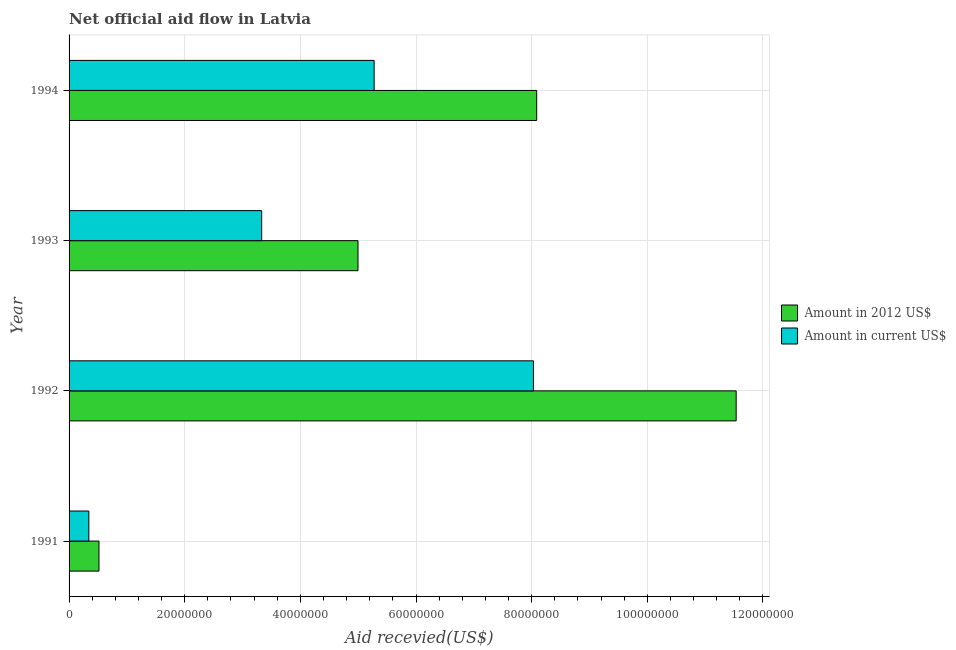How many bars are there on the 1st tick from the top?
Your answer should be very brief. 2. How many bars are there on the 2nd tick from the bottom?
Keep it short and to the point. 2. What is the amount of aid received(expressed in 2012 us$) in 1991?
Provide a short and direct response. 5.17e+06. Across all years, what is the maximum amount of aid received(expressed in us$)?
Ensure brevity in your answer.  8.03e+07. Across all years, what is the minimum amount of aid received(expressed in us$)?
Offer a terse response. 3.42e+06. In which year was the amount of aid received(expressed in us$) maximum?
Provide a succinct answer. 1992. What is the total amount of aid received(expressed in 2012 us$) in the graph?
Your answer should be very brief. 2.51e+08. What is the difference between the amount of aid received(expressed in us$) in 1991 and that in 1992?
Your answer should be very brief. -7.69e+07. What is the difference between the amount of aid received(expressed in us$) in 1991 and the amount of aid received(expressed in 2012 us$) in 1992?
Ensure brevity in your answer.  -1.12e+08. What is the average amount of aid received(expressed in us$) per year?
Offer a terse response. 4.24e+07. In the year 1993, what is the difference between the amount of aid received(expressed in 2012 us$) and amount of aid received(expressed in us$)?
Provide a succinct answer. 1.67e+07. What is the ratio of the amount of aid received(expressed in 2012 us$) in 1991 to that in 1992?
Give a very brief answer. 0.04. Is the amount of aid received(expressed in 2012 us$) in 1991 less than that in 1992?
Keep it short and to the point. Yes. Is the difference between the amount of aid received(expressed in 2012 us$) in 1992 and 1993 greater than the difference between the amount of aid received(expressed in us$) in 1992 and 1993?
Your answer should be very brief. Yes. What is the difference between the highest and the second highest amount of aid received(expressed in 2012 us$)?
Make the answer very short. 3.45e+07. What is the difference between the highest and the lowest amount of aid received(expressed in us$)?
Provide a succinct answer. 7.69e+07. In how many years, is the amount of aid received(expressed in 2012 us$) greater than the average amount of aid received(expressed in 2012 us$) taken over all years?
Keep it short and to the point. 2. Is the sum of the amount of aid received(expressed in 2012 us$) in 1992 and 1993 greater than the maximum amount of aid received(expressed in us$) across all years?
Provide a succinct answer. Yes. What does the 1st bar from the top in 1992 represents?
Offer a terse response. Amount in current US$. What does the 1st bar from the bottom in 1991 represents?
Give a very brief answer. Amount in 2012 US$. How many bars are there?
Your answer should be very brief. 8. Are all the bars in the graph horizontal?
Your answer should be compact. Yes. How many years are there in the graph?
Your response must be concise. 4. What is the difference between two consecutive major ticks on the X-axis?
Ensure brevity in your answer.  2.00e+07. Does the graph contain grids?
Your answer should be compact. Yes. How many legend labels are there?
Provide a short and direct response. 2. How are the legend labels stacked?
Your response must be concise. Vertical. What is the title of the graph?
Offer a very short reply. Net official aid flow in Latvia. Does "Number of arrivals" appear as one of the legend labels in the graph?
Make the answer very short. No. What is the label or title of the X-axis?
Keep it short and to the point. Aid recevied(US$). What is the label or title of the Y-axis?
Your answer should be compact. Year. What is the Aid recevied(US$) of Amount in 2012 US$ in 1991?
Ensure brevity in your answer.  5.17e+06. What is the Aid recevied(US$) in Amount in current US$ in 1991?
Give a very brief answer. 3.42e+06. What is the Aid recevied(US$) of Amount in 2012 US$ in 1992?
Your response must be concise. 1.15e+08. What is the Aid recevied(US$) of Amount in current US$ in 1992?
Your response must be concise. 8.03e+07. What is the Aid recevied(US$) of Amount in 2012 US$ in 1993?
Your answer should be very brief. 5.00e+07. What is the Aid recevied(US$) of Amount in current US$ in 1993?
Ensure brevity in your answer.  3.33e+07. What is the Aid recevied(US$) of Amount in 2012 US$ in 1994?
Your answer should be very brief. 8.09e+07. What is the Aid recevied(US$) in Amount in current US$ in 1994?
Your answer should be very brief. 5.28e+07. Across all years, what is the maximum Aid recevied(US$) of Amount in 2012 US$?
Your answer should be very brief. 1.15e+08. Across all years, what is the maximum Aid recevied(US$) of Amount in current US$?
Provide a short and direct response. 8.03e+07. Across all years, what is the minimum Aid recevied(US$) in Amount in 2012 US$?
Make the answer very short. 5.17e+06. Across all years, what is the minimum Aid recevied(US$) in Amount in current US$?
Make the answer very short. 3.42e+06. What is the total Aid recevied(US$) in Amount in 2012 US$ in the graph?
Your response must be concise. 2.51e+08. What is the total Aid recevied(US$) in Amount in current US$ in the graph?
Ensure brevity in your answer.  1.70e+08. What is the difference between the Aid recevied(US$) of Amount in 2012 US$ in 1991 and that in 1992?
Offer a very short reply. -1.10e+08. What is the difference between the Aid recevied(US$) of Amount in current US$ in 1991 and that in 1992?
Your answer should be very brief. -7.69e+07. What is the difference between the Aid recevied(US$) of Amount in 2012 US$ in 1991 and that in 1993?
Offer a terse response. -4.48e+07. What is the difference between the Aid recevied(US$) of Amount in current US$ in 1991 and that in 1993?
Offer a terse response. -2.99e+07. What is the difference between the Aid recevied(US$) in Amount in 2012 US$ in 1991 and that in 1994?
Ensure brevity in your answer.  -7.57e+07. What is the difference between the Aid recevied(US$) of Amount in current US$ in 1991 and that in 1994?
Give a very brief answer. -4.93e+07. What is the difference between the Aid recevied(US$) of Amount in 2012 US$ in 1992 and that in 1993?
Your response must be concise. 6.54e+07. What is the difference between the Aid recevied(US$) in Amount in current US$ in 1992 and that in 1993?
Make the answer very short. 4.70e+07. What is the difference between the Aid recevied(US$) of Amount in 2012 US$ in 1992 and that in 1994?
Your answer should be compact. 3.45e+07. What is the difference between the Aid recevied(US$) in Amount in current US$ in 1992 and that in 1994?
Your response must be concise. 2.76e+07. What is the difference between the Aid recevied(US$) in Amount in 2012 US$ in 1993 and that in 1994?
Keep it short and to the point. -3.09e+07. What is the difference between the Aid recevied(US$) in Amount in current US$ in 1993 and that in 1994?
Offer a very short reply. -1.94e+07. What is the difference between the Aid recevied(US$) of Amount in 2012 US$ in 1991 and the Aid recevied(US$) of Amount in current US$ in 1992?
Ensure brevity in your answer.  -7.51e+07. What is the difference between the Aid recevied(US$) in Amount in 2012 US$ in 1991 and the Aid recevied(US$) in Amount in current US$ in 1993?
Ensure brevity in your answer.  -2.81e+07. What is the difference between the Aid recevied(US$) in Amount in 2012 US$ in 1991 and the Aid recevied(US$) in Amount in current US$ in 1994?
Your response must be concise. -4.76e+07. What is the difference between the Aid recevied(US$) in Amount in 2012 US$ in 1992 and the Aid recevied(US$) in Amount in current US$ in 1993?
Your answer should be compact. 8.21e+07. What is the difference between the Aid recevied(US$) in Amount in 2012 US$ in 1992 and the Aid recevied(US$) in Amount in current US$ in 1994?
Provide a short and direct response. 6.26e+07. What is the difference between the Aid recevied(US$) in Amount in 2012 US$ in 1993 and the Aid recevied(US$) in Amount in current US$ in 1994?
Provide a short and direct response. -2.79e+06. What is the average Aid recevied(US$) of Amount in 2012 US$ per year?
Make the answer very short. 6.28e+07. What is the average Aid recevied(US$) in Amount in current US$ per year?
Provide a short and direct response. 4.24e+07. In the year 1991, what is the difference between the Aid recevied(US$) in Amount in 2012 US$ and Aid recevied(US$) in Amount in current US$?
Give a very brief answer. 1.75e+06. In the year 1992, what is the difference between the Aid recevied(US$) in Amount in 2012 US$ and Aid recevied(US$) in Amount in current US$?
Provide a succinct answer. 3.51e+07. In the year 1993, what is the difference between the Aid recevied(US$) in Amount in 2012 US$ and Aid recevied(US$) in Amount in current US$?
Keep it short and to the point. 1.67e+07. In the year 1994, what is the difference between the Aid recevied(US$) of Amount in 2012 US$ and Aid recevied(US$) of Amount in current US$?
Provide a short and direct response. 2.81e+07. What is the ratio of the Aid recevied(US$) in Amount in 2012 US$ in 1991 to that in 1992?
Provide a succinct answer. 0.04. What is the ratio of the Aid recevied(US$) of Amount in current US$ in 1991 to that in 1992?
Give a very brief answer. 0.04. What is the ratio of the Aid recevied(US$) in Amount in 2012 US$ in 1991 to that in 1993?
Provide a short and direct response. 0.1. What is the ratio of the Aid recevied(US$) in Amount in current US$ in 1991 to that in 1993?
Provide a short and direct response. 0.1. What is the ratio of the Aid recevied(US$) in Amount in 2012 US$ in 1991 to that in 1994?
Make the answer very short. 0.06. What is the ratio of the Aid recevied(US$) of Amount in current US$ in 1991 to that in 1994?
Ensure brevity in your answer.  0.06. What is the ratio of the Aid recevied(US$) of Amount in 2012 US$ in 1992 to that in 1993?
Keep it short and to the point. 2.31. What is the ratio of the Aid recevied(US$) in Amount in current US$ in 1992 to that in 1993?
Provide a short and direct response. 2.41. What is the ratio of the Aid recevied(US$) of Amount in 2012 US$ in 1992 to that in 1994?
Ensure brevity in your answer.  1.43. What is the ratio of the Aid recevied(US$) of Amount in current US$ in 1992 to that in 1994?
Your answer should be very brief. 1.52. What is the ratio of the Aid recevied(US$) of Amount in 2012 US$ in 1993 to that in 1994?
Your answer should be compact. 0.62. What is the ratio of the Aid recevied(US$) of Amount in current US$ in 1993 to that in 1994?
Ensure brevity in your answer.  0.63. What is the difference between the highest and the second highest Aid recevied(US$) in Amount in 2012 US$?
Offer a terse response. 3.45e+07. What is the difference between the highest and the second highest Aid recevied(US$) of Amount in current US$?
Offer a very short reply. 2.76e+07. What is the difference between the highest and the lowest Aid recevied(US$) of Amount in 2012 US$?
Keep it short and to the point. 1.10e+08. What is the difference between the highest and the lowest Aid recevied(US$) of Amount in current US$?
Keep it short and to the point. 7.69e+07. 